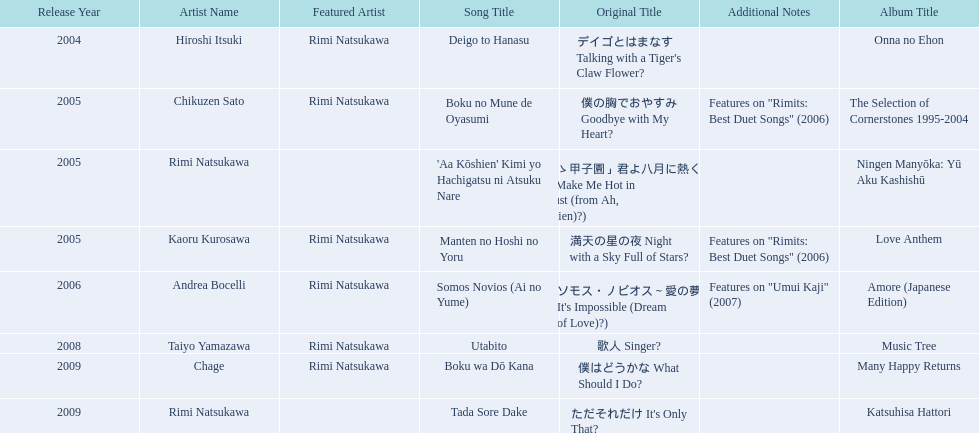What are the names of each album by rimi natsukawa? Onna no Ehon, The Selection of Cornerstones 1995-2004, Ningen Manyōka: Yū Aku Kashishū, Love Anthem, Amore (Japanese Edition), Music Tree, Many Happy Returns, Katsuhisa Hattori. And when were the albums released? 2004, 2005, 2005, 2005, 2006, 2008, 2009, 2009. Was onna no ehon or music tree released most recently? Music Tree. 